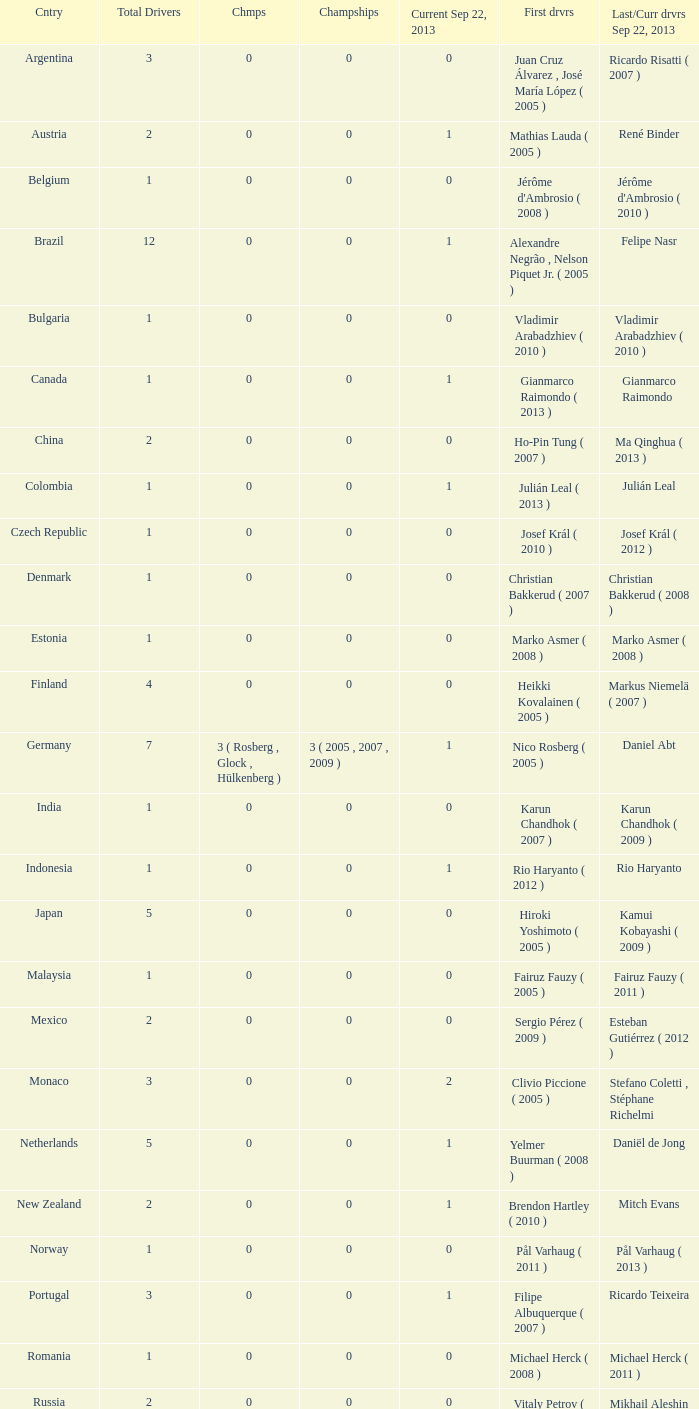How many entries are there for total drivers when the Last driver for september 22, 2013 was gianmarco raimondo? 1.0. 